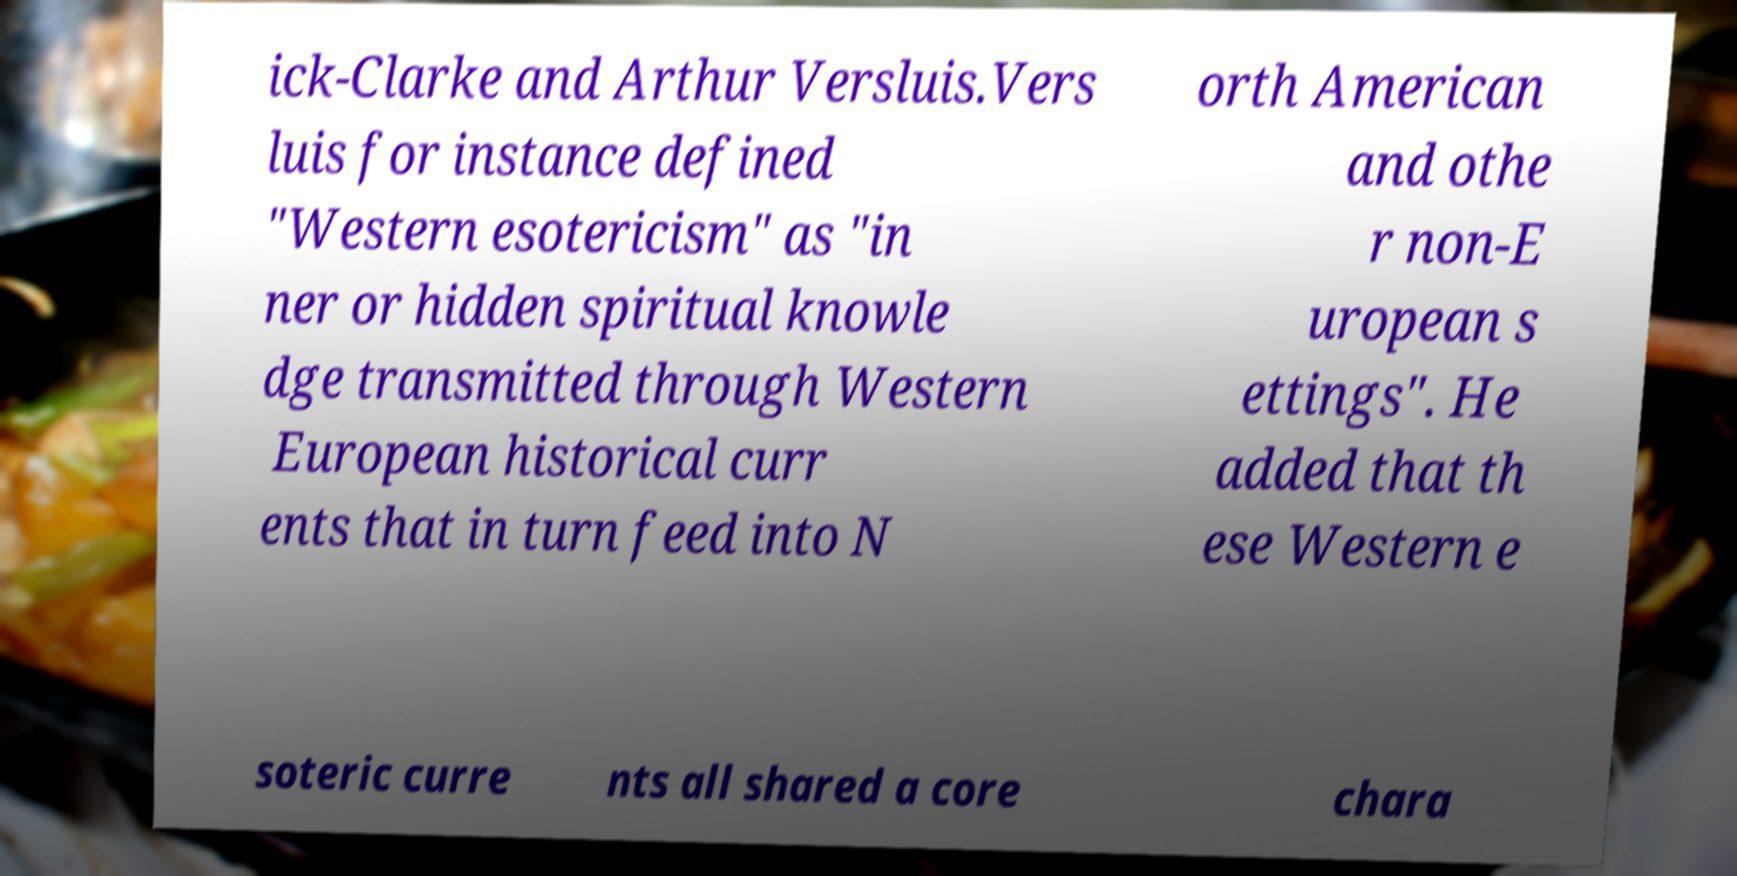Can you accurately transcribe the text from the provided image for me? ick-Clarke and Arthur Versluis.Vers luis for instance defined "Western esotericism" as "in ner or hidden spiritual knowle dge transmitted through Western European historical curr ents that in turn feed into N orth American and othe r non-E uropean s ettings". He added that th ese Western e soteric curre nts all shared a core chara 